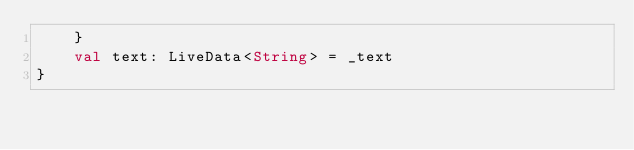<code> <loc_0><loc_0><loc_500><loc_500><_Kotlin_>    }
    val text: LiveData<String> = _text
}</code> 